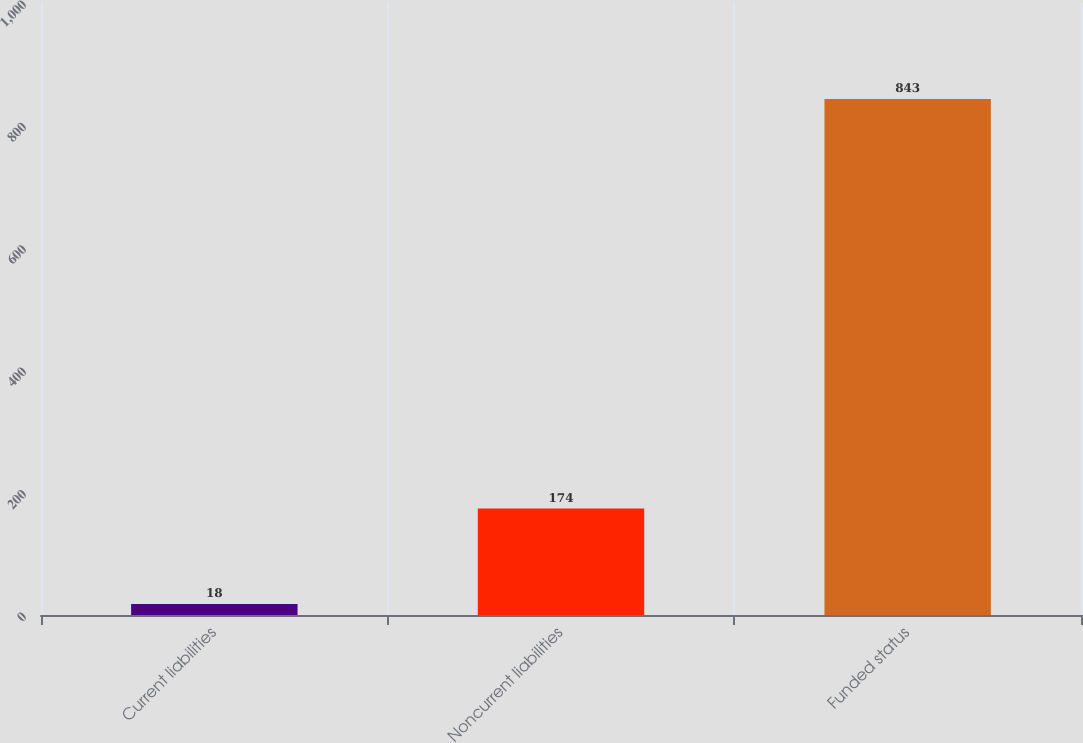Convert chart to OTSL. <chart><loc_0><loc_0><loc_500><loc_500><bar_chart><fcel>Current liabilities<fcel>Noncurrent liabilities<fcel>Funded status<nl><fcel>18<fcel>174<fcel>843<nl></chart> 